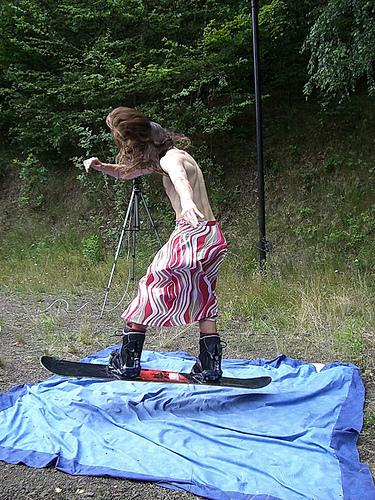Question: where are the trees?
Choices:
A. Behind the clearing.
B. Between the houses.
C. Background.
D. In the yard.
Answer with the letter. Answer: C Question: what is on the teens feet?
Choices:
A. Snowboarding boots.
B. Boots.
C. Skis.
D. Snowshoes.
Answer with the letter. Answer: A Question: why is the tripod there?
Choices:
A. Hold camera.
B. For the video.
C. To tape the event.
D. For the photographer to be included in the photo.
Answer with the letter. Answer: A Question: who is in the picture?
Choices:
A. A family.
B. The teenager.
C. The grandparents.
D. Students.
Answer with the letter. Answer: B Question: when is the picture taken?
Choices:
A. Day time.
B. At Christmas time.
C. In the winter.
D. On New Year's Eve.
Answer with the letter. Answer: A 